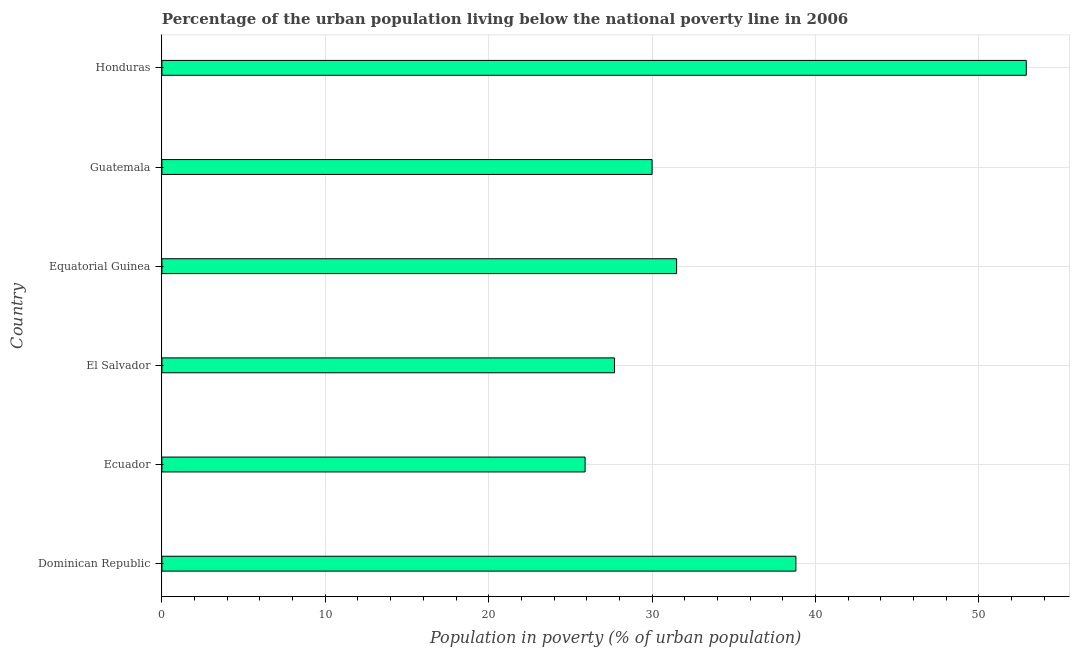Does the graph contain any zero values?
Provide a succinct answer. No. What is the title of the graph?
Your answer should be compact. Percentage of the urban population living below the national poverty line in 2006. What is the label or title of the X-axis?
Your answer should be very brief. Population in poverty (% of urban population). What is the label or title of the Y-axis?
Keep it short and to the point. Country. What is the percentage of urban population living below poverty line in Ecuador?
Your response must be concise. 25.9. Across all countries, what is the maximum percentage of urban population living below poverty line?
Give a very brief answer. 52.9. Across all countries, what is the minimum percentage of urban population living below poverty line?
Make the answer very short. 25.9. In which country was the percentage of urban population living below poverty line maximum?
Your answer should be very brief. Honduras. In which country was the percentage of urban population living below poverty line minimum?
Your answer should be very brief. Ecuador. What is the sum of the percentage of urban population living below poverty line?
Make the answer very short. 206.8. What is the difference between the percentage of urban population living below poverty line in Dominican Republic and El Salvador?
Your response must be concise. 11.1. What is the average percentage of urban population living below poverty line per country?
Your answer should be very brief. 34.47. What is the median percentage of urban population living below poverty line?
Provide a short and direct response. 30.75. What is the ratio of the percentage of urban population living below poverty line in Ecuador to that in Equatorial Guinea?
Make the answer very short. 0.82. Is the percentage of urban population living below poverty line in El Salvador less than that in Honduras?
Make the answer very short. Yes. What is the difference between the highest and the second highest percentage of urban population living below poverty line?
Your answer should be very brief. 14.1. Is the sum of the percentage of urban population living below poverty line in El Salvador and Honduras greater than the maximum percentage of urban population living below poverty line across all countries?
Provide a short and direct response. Yes. Are all the bars in the graph horizontal?
Your response must be concise. Yes. How many countries are there in the graph?
Offer a terse response. 6. What is the difference between two consecutive major ticks on the X-axis?
Ensure brevity in your answer.  10. What is the Population in poverty (% of urban population) of Dominican Republic?
Offer a terse response. 38.8. What is the Population in poverty (% of urban population) in Ecuador?
Give a very brief answer. 25.9. What is the Population in poverty (% of urban population) of El Salvador?
Provide a succinct answer. 27.7. What is the Population in poverty (% of urban population) of Equatorial Guinea?
Offer a very short reply. 31.5. What is the Population in poverty (% of urban population) in Guatemala?
Make the answer very short. 30. What is the Population in poverty (% of urban population) of Honduras?
Give a very brief answer. 52.9. What is the difference between the Population in poverty (% of urban population) in Dominican Republic and El Salvador?
Provide a succinct answer. 11.1. What is the difference between the Population in poverty (% of urban population) in Dominican Republic and Equatorial Guinea?
Provide a short and direct response. 7.3. What is the difference between the Population in poverty (% of urban population) in Dominican Republic and Guatemala?
Your response must be concise. 8.8. What is the difference between the Population in poverty (% of urban population) in Dominican Republic and Honduras?
Keep it short and to the point. -14.1. What is the difference between the Population in poverty (% of urban population) in Ecuador and El Salvador?
Make the answer very short. -1.8. What is the difference between the Population in poverty (% of urban population) in Ecuador and Guatemala?
Keep it short and to the point. -4.1. What is the difference between the Population in poverty (% of urban population) in El Salvador and Equatorial Guinea?
Keep it short and to the point. -3.8. What is the difference between the Population in poverty (% of urban population) in El Salvador and Guatemala?
Offer a terse response. -2.3. What is the difference between the Population in poverty (% of urban population) in El Salvador and Honduras?
Your response must be concise. -25.2. What is the difference between the Population in poverty (% of urban population) in Equatorial Guinea and Honduras?
Keep it short and to the point. -21.4. What is the difference between the Population in poverty (% of urban population) in Guatemala and Honduras?
Give a very brief answer. -22.9. What is the ratio of the Population in poverty (% of urban population) in Dominican Republic to that in Ecuador?
Your response must be concise. 1.5. What is the ratio of the Population in poverty (% of urban population) in Dominican Republic to that in El Salvador?
Your answer should be very brief. 1.4. What is the ratio of the Population in poverty (% of urban population) in Dominican Republic to that in Equatorial Guinea?
Make the answer very short. 1.23. What is the ratio of the Population in poverty (% of urban population) in Dominican Republic to that in Guatemala?
Keep it short and to the point. 1.29. What is the ratio of the Population in poverty (% of urban population) in Dominican Republic to that in Honduras?
Keep it short and to the point. 0.73. What is the ratio of the Population in poverty (% of urban population) in Ecuador to that in El Salvador?
Provide a short and direct response. 0.94. What is the ratio of the Population in poverty (% of urban population) in Ecuador to that in Equatorial Guinea?
Offer a very short reply. 0.82. What is the ratio of the Population in poverty (% of urban population) in Ecuador to that in Guatemala?
Your answer should be very brief. 0.86. What is the ratio of the Population in poverty (% of urban population) in Ecuador to that in Honduras?
Your response must be concise. 0.49. What is the ratio of the Population in poverty (% of urban population) in El Salvador to that in Equatorial Guinea?
Give a very brief answer. 0.88. What is the ratio of the Population in poverty (% of urban population) in El Salvador to that in Guatemala?
Keep it short and to the point. 0.92. What is the ratio of the Population in poverty (% of urban population) in El Salvador to that in Honduras?
Give a very brief answer. 0.52. What is the ratio of the Population in poverty (% of urban population) in Equatorial Guinea to that in Honduras?
Provide a succinct answer. 0.59. What is the ratio of the Population in poverty (% of urban population) in Guatemala to that in Honduras?
Keep it short and to the point. 0.57. 